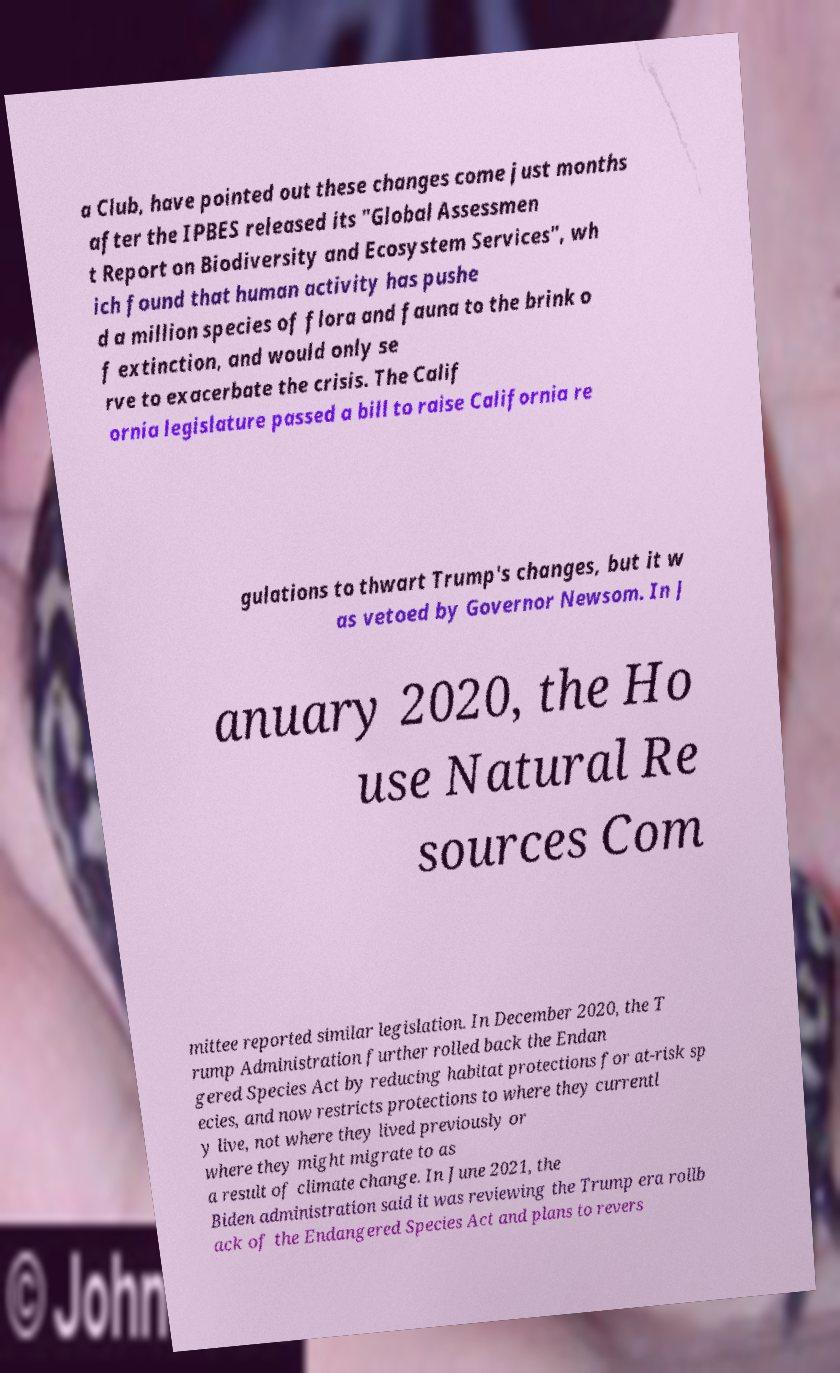I need the written content from this picture converted into text. Can you do that? a Club, have pointed out these changes come just months after the IPBES released its "Global Assessmen t Report on Biodiversity and Ecosystem Services", wh ich found that human activity has pushe d a million species of flora and fauna to the brink o f extinction, and would only se rve to exacerbate the crisis. The Calif ornia legislature passed a bill to raise California re gulations to thwart Trump's changes, but it w as vetoed by Governor Newsom. In J anuary 2020, the Ho use Natural Re sources Com mittee reported similar legislation. In December 2020, the T rump Administration further rolled back the Endan gered Species Act by reducing habitat protections for at-risk sp ecies, and now restricts protections to where they currentl y live, not where they lived previously or where they might migrate to as a result of climate change. In June 2021, the Biden administration said it was reviewing the Trump era rollb ack of the Endangered Species Act and plans to revers 